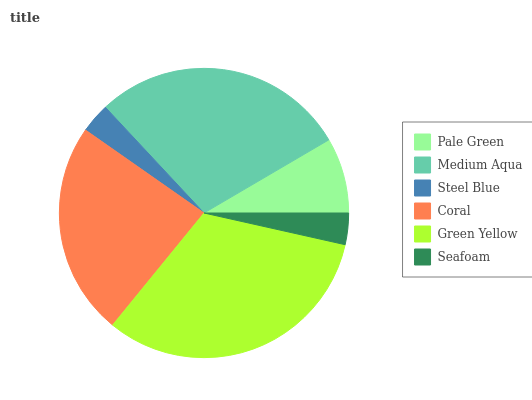Is Steel Blue the minimum?
Answer yes or no. Yes. Is Green Yellow the maximum?
Answer yes or no. Yes. Is Medium Aqua the minimum?
Answer yes or no. No. Is Medium Aqua the maximum?
Answer yes or no. No. Is Medium Aqua greater than Pale Green?
Answer yes or no. Yes. Is Pale Green less than Medium Aqua?
Answer yes or no. Yes. Is Pale Green greater than Medium Aqua?
Answer yes or no. No. Is Medium Aqua less than Pale Green?
Answer yes or no. No. Is Coral the high median?
Answer yes or no. Yes. Is Pale Green the low median?
Answer yes or no. Yes. Is Steel Blue the high median?
Answer yes or no. No. Is Medium Aqua the low median?
Answer yes or no. No. 